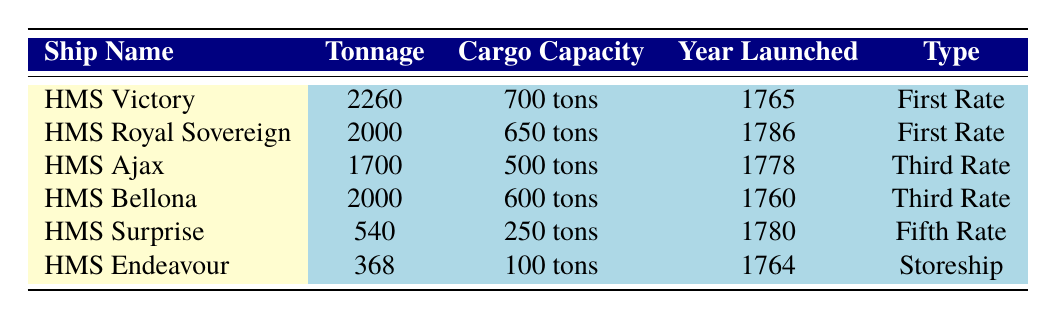What is the tonnage of HMS Victory? The table lists the tonnage for each ship. For HMS Victory, the tonnage is explicitly stated as 2260.
Answer: 2260 What is the cargo capacity of HMS Surprise? Looking at the row for HMS Surprise, the cargo capacity is indicated as 250 tons.
Answer: 250 tons What is the year of launch for HMS Royal Sovereign? The table includes a column for the year each ship was launched. HMS Royal Sovereign was launched in 1786.
Answer: 1786 Which ship has the highest tonnage? To find the ship with the highest tonnage, we can compare the tonnage values: 2260 for HMS Victory, 2000 for HMS Royal Sovereign and HMS Bellona, 1700 for HMS Ajax, 540 for HMS Surprise, and 368 for HMS Endeavour. HMS Victory has the highest tonnage at 2260.
Answer: HMS Victory Is HMS Bellona a First Rate ship? By checking the type listed in the table for HMS Bellona, it is classified as a "Third Rate", so it is not a First Rate ship.
Answer: No What is the average cargo capacity of the First Rate ships? The First Rate ships are HMS Victory and HMS Royal Sovereign with cargo capacities of 700 tons and 650 tons respectively. Adding these gives a total of 1350 tons. Dividing by the number of First Rate ships (2) gives an average of 675 tons.
Answer: 675 tons Which ship has a cargo capacity less than 300 tons? Examining the cargo capacity column, HMS Endeavour has a cargo capacity of 100 tons, and HMS Surprise has a cargo capacity of 250 tons. Both are below 300 tons.
Answer: HMS Endeavour and HMS Surprise How much more cargo can HMS Royal Sovereign carry compared to HMS Ajax? For HMS Royal Sovereign, the cargo capacity is 650 tons, and for HMS Ajax, it is 500 tons. The difference is 650 - 500 = 150 tons, indicating that HMS Royal Sovereign can carry 150 tons more.
Answer: 150 tons Is there a ship with a cargo capacity of exactly 600 tons? Checking the cargo capacities in the table reveals that HMS Bellona has a cargo capacity of 600 tons. Therefore, there is a ship that meets this criterion.
Answer: Yes 